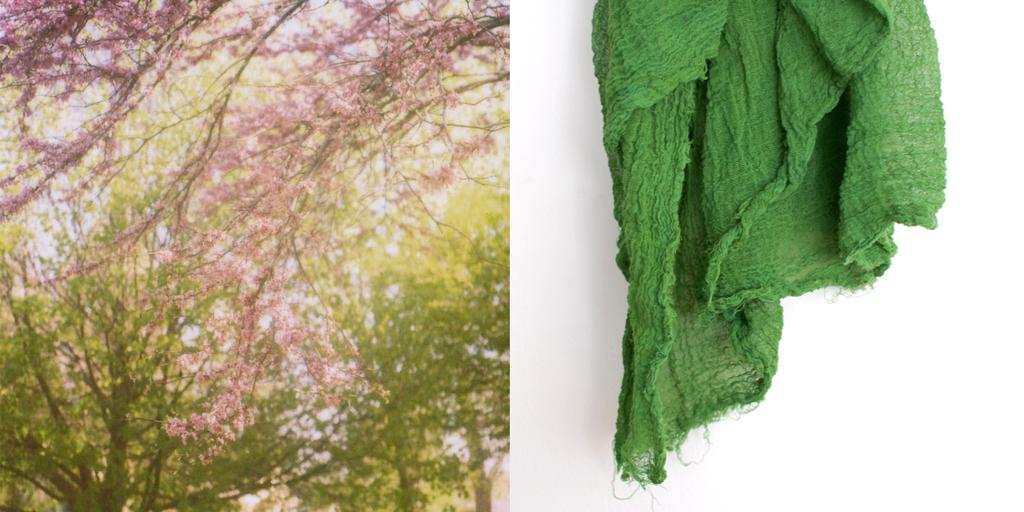What type of vegetation can be seen in the image? There are trees in the image. What other natural elements are present in the image? There are flowers in the image. What object can be seen on the right side of the image? There is a cloth on the right side of the image. What is the representative's opinion on the digestion process in the image? There is no representative or discussion of digestion in the image; it features trees, flowers, and a cloth. 